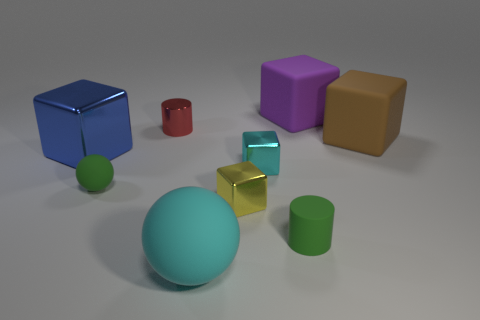Are there any other things of the same color as the tiny rubber ball?
Your answer should be compact. Yes. How many things are either yellow metal cubes or green rubber objects?
Your answer should be compact. 3. Is the size of the green rubber object that is left of the matte cylinder the same as the yellow shiny block?
Keep it short and to the point. Yes. What number of other objects are the same size as the brown thing?
Provide a succinct answer. 3. Are any balls visible?
Provide a succinct answer. Yes. There is a cylinder in front of the small metal object that is behind the big blue object; how big is it?
Offer a very short reply. Small. Do the big matte cube in front of the purple rubber block and the cylinder that is right of the cyan ball have the same color?
Your answer should be compact. No. What is the color of the thing that is behind the green cylinder and in front of the green sphere?
Your response must be concise. Yellow. What number of other objects are the same shape as the purple object?
Keep it short and to the point. 4. What is the color of the shiny cylinder that is the same size as the green matte cylinder?
Offer a terse response. Red. 